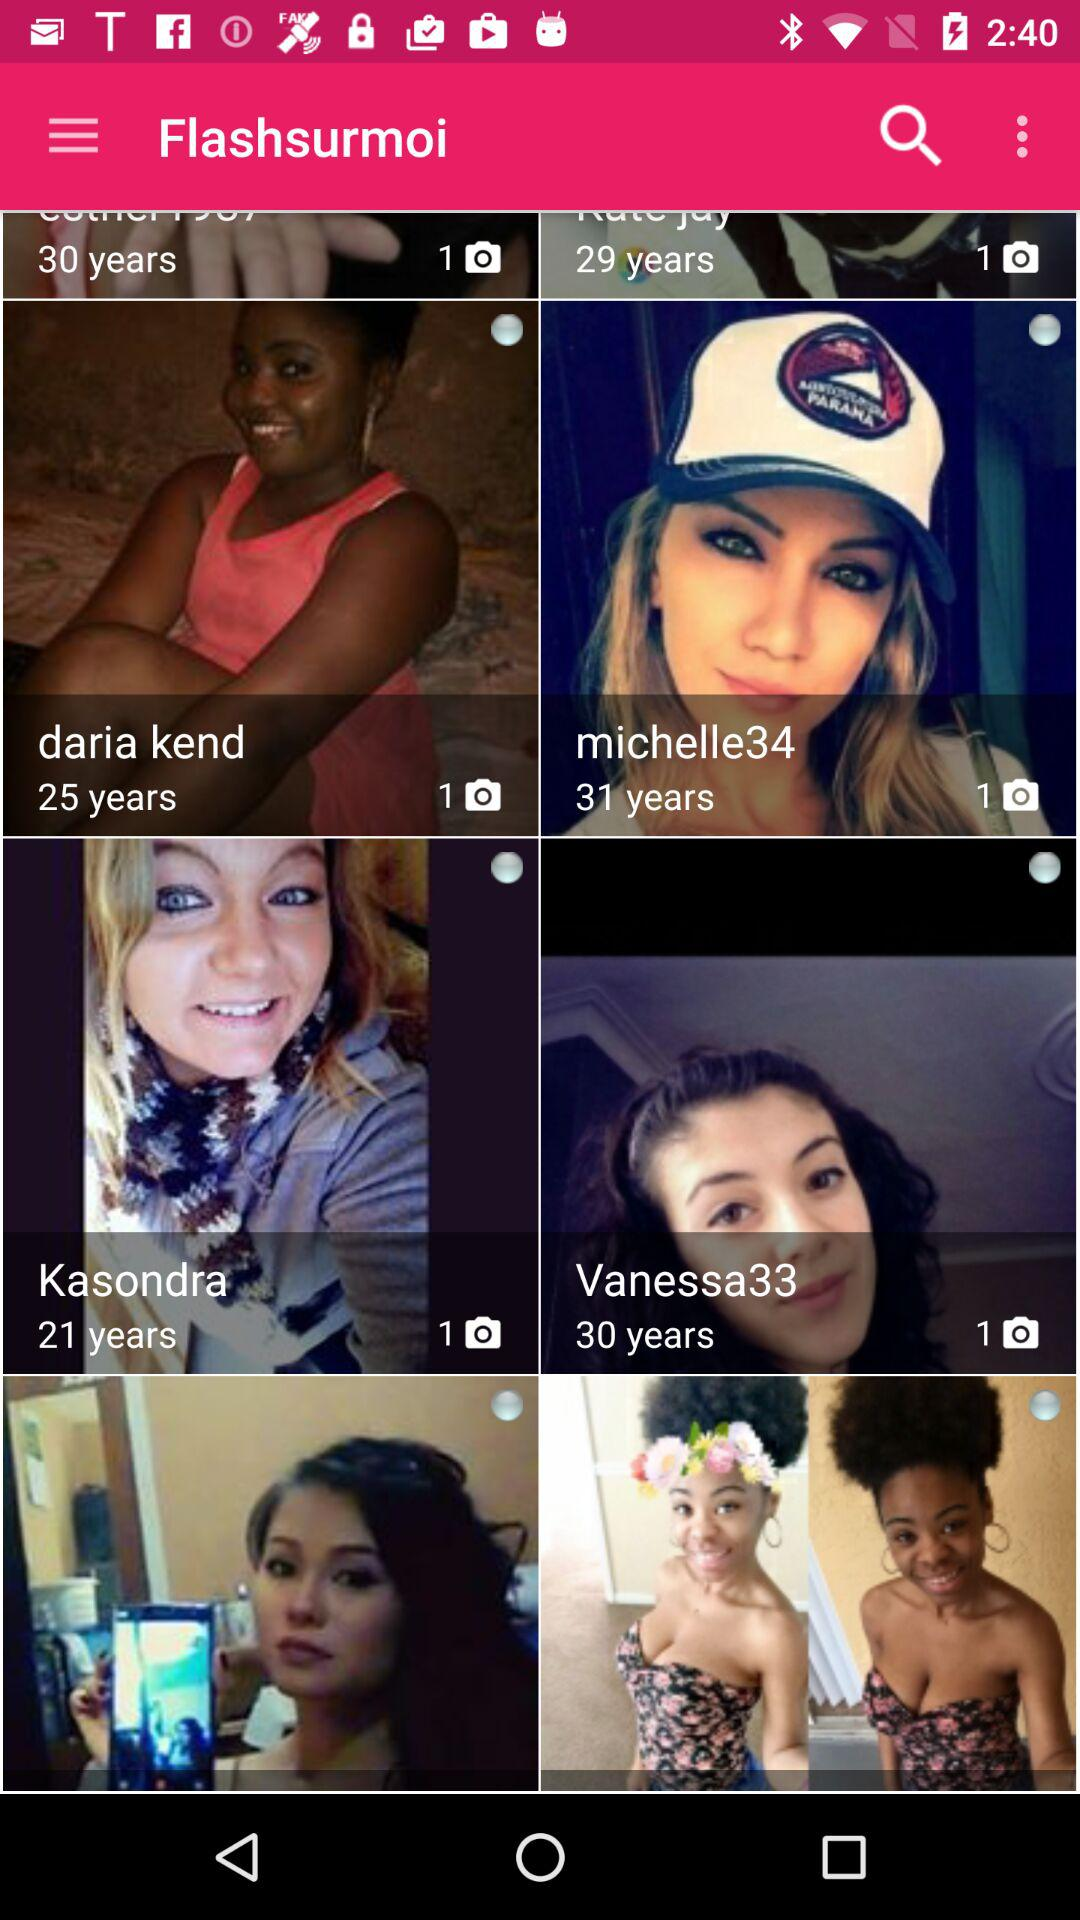Whose age is 21 years? The age of Kasondra is 21 years. 